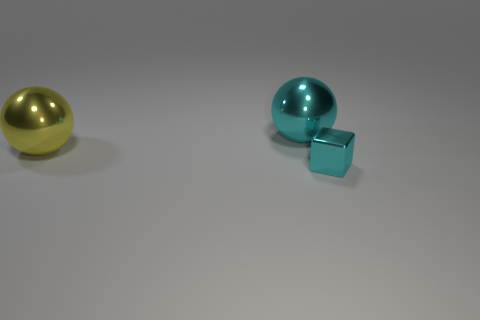Add 2 large shiny balls. How many objects exist? 5 Subtract 0 green cubes. How many objects are left? 3 Subtract all balls. How many objects are left? 1 Subtract all blue cubes. Subtract all red cylinders. How many cubes are left? 1 Subtract all purple blocks. How many yellow spheres are left? 1 Subtract all cyan metal balls. Subtract all large cyan matte cylinders. How many objects are left? 2 Add 2 large yellow spheres. How many large yellow spheres are left? 3 Add 2 big cyan metallic things. How many big cyan metallic things exist? 3 